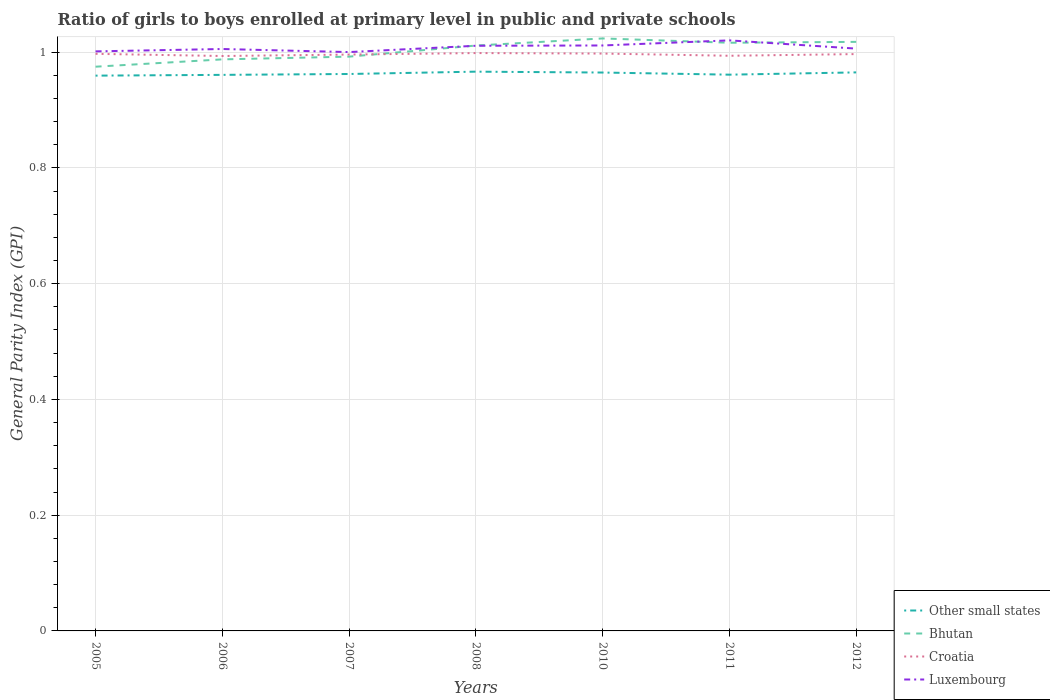How many different coloured lines are there?
Your response must be concise. 4. Is the number of lines equal to the number of legend labels?
Give a very brief answer. Yes. Across all years, what is the maximum general parity index in Croatia?
Keep it short and to the point. 0.99. In which year was the general parity index in Croatia maximum?
Your answer should be compact. 2006. What is the total general parity index in Other small states in the graph?
Ensure brevity in your answer.  -0. What is the difference between the highest and the second highest general parity index in Luxembourg?
Your answer should be compact. 0.02. Is the general parity index in Luxembourg strictly greater than the general parity index in Croatia over the years?
Give a very brief answer. No. How many years are there in the graph?
Your answer should be very brief. 7. Are the values on the major ticks of Y-axis written in scientific E-notation?
Offer a very short reply. No. Does the graph contain any zero values?
Give a very brief answer. No. Where does the legend appear in the graph?
Offer a terse response. Bottom right. How are the legend labels stacked?
Give a very brief answer. Vertical. What is the title of the graph?
Provide a short and direct response. Ratio of girls to boys enrolled at primary level in public and private schools. Does "Egypt, Arab Rep." appear as one of the legend labels in the graph?
Your answer should be very brief. No. What is the label or title of the X-axis?
Give a very brief answer. Years. What is the label or title of the Y-axis?
Ensure brevity in your answer.  General Parity Index (GPI). What is the General Parity Index (GPI) of Other small states in 2005?
Provide a succinct answer. 0.96. What is the General Parity Index (GPI) in Bhutan in 2005?
Your response must be concise. 0.97. What is the General Parity Index (GPI) of Croatia in 2005?
Keep it short and to the point. 1. What is the General Parity Index (GPI) in Luxembourg in 2005?
Your response must be concise. 1. What is the General Parity Index (GPI) in Other small states in 2006?
Your response must be concise. 0.96. What is the General Parity Index (GPI) in Bhutan in 2006?
Give a very brief answer. 0.99. What is the General Parity Index (GPI) in Croatia in 2006?
Make the answer very short. 0.99. What is the General Parity Index (GPI) in Luxembourg in 2006?
Your response must be concise. 1.01. What is the General Parity Index (GPI) in Other small states in 2007?
Provide a short and direct response. 0.96. What is the General Parity Index (GPI) in Bhutan in 2007?
Your answer should be very brief. 0.99. What is the General Parity Index (GPI) of Croatia in 2007?
Your response must be concise. 1. What is the General Parity Index (GPI) of Luxembourg in 2007?
Ensure brevity in your answer.  1. What is the General Parity Index (GPI) of Other small states in 2008?
Ensure brevity in your answer.  0.97. What is the General Parity Index (GPI) in Bhutan in 2008?
Keep it short and to the point. 1.01. What is the General Parity Index (GPI) of Croatia in 2008?
Offer a terse response. 1. What is the General Parity Index (GPI) in Luxembourg in 2008?
Provide a succinct answer. 1.01. What is the General Parity Index (GPI) in Other small states in 2010?
Offer a terse response. 0.96. What is the General Parity Index (GPI) in Bhutan in 2010?
Make the answer very short. 1.02. What is the General Parity Index (GPI) of Croatia in 2010?
Provide a succinct answer. 1. What is the General Parity Index (GPI) of Luxembourg in 2010?
Ensure brevity in your answer.  1.01. What is the General Parity Index (GPI) in Other small states in 2011?
Your answer should be compact. 0.96. What is the General Parity Index (GPI) of Bhutan in 2011?
Offer a very short reply. 1.02. What is the General Parity Index (GPI) in Croatia in 2011?
Make the answer very short. 0.99. What is the General Parity Index (GPI) of Luxembourg in 2011?
Your answer should be very brief. 1.02. What is the General Parity Index (GPI) in Other small states in 2012?
Offer a very short reply. 0.97. What is the General Parity Index (GPI) in Bhutan in 2012?
Keep it short and to the point. 1.02. What is the General Parity Index (GPI) of Croatia in 2012?
Make the answer very short. 1. What is the General Parity Index (GPI) of Luxembourg in 2012?
Offer a very short reply. 1.01. Across all years, what is the maximum General Parity Index (GPI) in Other small states?
Give a very brief answer. 0.97. Across all years, what is the maximum General Parity Index (GPI) in Bhutan?
Offer a terse response. 1.02. Across all years, what is the maximum General Parity Index (GPI) of Croatia?
Keep it short and to the point. 1. Across all years, what is the maximum General Parity Index (GPI) in Luxembourg?
Keep it short and to the point. 1.02. Across all years, what is the minimum General Parity Index (GPI) of Other small states?
Give a very brief answer. 0.96. Across all years, what is the minimum General Parity Index (GPI) of Bhutan?
Ensure brevity in your answer.  0.97. Across all years, what is the minimum General Parity Index (GPI) of Croatia?
Ensure brevity in your answer.  0.99. Across all years, what is the minimum General Parity Index (GPI) in Luxembourg?
Provide a succinct answer. 1. What is the total General Parity Index (GPI) of Other small states in the graph?
Your answer should be compact. 6.74. What is the total General Parity Index (GPI) in Bhutan in the graph?
Give a very brief answer. 7.02. What is the total General Parity Index (GPI) in Croatia in the graph?
Make the answer very short. 6.97. What is the total General Parity Index (GPI) of Luxembourg in the graph?
Offer a terse response. 7.06. What is the difference between the General Parity Index (GPI) in Other small states in 2005 and that in 2006?
Offer a terse response. -0. What is the difference between the General Parity Index (GPI) of Bhutan in 2005 and that in 2006?
Offer a very short reply. -0.01. What is the difference between the General Parity Index (GPI) of Croatia in 2005 and that in 2006?
Ensure brevity in your answer.  0. What is the difference between the General Parity Index (GPI) of Luxembourg in 2005 and that in 2006?
Keep it short and to the point. -0. What is the difference between the General Parity Index (GPI) in Other small states in 2005 and that in 2007?
Give a very brief answer. -0. What is the difference between the General Parity Index (GPI) in Bhutan in 2005 and that in 2007?
Offer a terse response. -0.02. What is the difference between the General Parity Index (GPI) in Croatia in 2005 and that in 2007?
Give a very brief answer. 0. What is the difference between the General Parity Index (GPI) of Luxembourg in 2005 and that in 2007?
Your answer should be very brief. 0. What is the difference between the General Parity Index (GPI) of Other small states in 2005 and that in 2008?
Your answer should be compact. -0.01. What is the difference between the General Parity Index (GPI) of Bhutan in 2005 and that in 2008?
Offer a very short reply. -0.04. What is the difference between the General Parity Index (GPI) of Croatia in 2005 and that in 2008?
Your answer should be compact. -0. What is the difference between the General Parity Index (GPI) in Luxembourg in 2005 and that in 2008?
Offer a very short reply. -0.01. What is the difference between the General Parity Index (GPI) in Other small states in 2005 and that in 2010?
Offer a terse response. -0.01. What is the difference between the General Parity Index (GPI) in Bhutan in 2005 and that in 2010?
Your response must be concise. -0.05. What is the difference between the General Parity Index (GPI) of Croatia in 2005 and that in 2010?
Provide a succinct answer. -0. What is the difference between the General Parity Index (GPI) of Luxembourg in 2005 and that in 2010?
Offer a terse response. -0.01. What is the difference between the General Parity Index (GPI) in Other small states in 2005 and that in 2011?
Offer a terse response. -0. What is the difference between the General Parity Index (GPI) of Bhutan in 2005 and that in 2011?
Keep it short and to the point. -0.04. What is the difference between the General Parity Index (GPI) of Croatia in 2005 and that in 2011?
Offer a terse response. 0. What is the difference between the General Parity Index (GPI) of Luxembourg in 2005 and that in 2011?
Your answer should be compact. -0.02. What is the difference between the General Parity Index (GPI) in Other small states in 2005 and that in 2012?
Make the answer very short. -0.01. What is the difference between the General Parity Index (GPI) in Bhutan in 2005 and that in 2012?
Your answer should be compact. -0.04. What is the difference between the General Parity Index (GPI) in Luxembourg in 2005 and that in 2012?
Give a very brief answer. -0. What is the difference between the General Parity Index (GPI) of Other small states in 2006 and that in 2007?
Make the answer very short. -0. What is the difference between the General Parity Index (GPI) in Bhutan in 2006 and that in 2007?
Your answer should be very brief. -0. What is the difference between the General Parity Index (GPI) in Croatia in 2006 and that in 2007?
Your response must be concise. -0. What is the difference between the General Parity Index (GPI) of Luxembourg in 2006 and that in 2007?
Make the answer very short. 0.01. What is the difference between the General Parity Index (GPI) in Other small states in 2006 and that in 2008?
Give a very brief answer. -0.01. What is the difference between the General Parity Index (GPI) of Bhutan in 2006 and that in 2008?
Keep it short and to the point. -0.02. What is the difference between the General Parity Index (GPI) of Croatia in 2006 and that in 2008?
Your answer should be compact. -0.01. What is the difference between the General Parity Index (GPI) in Luxembourg in 2006 and that in 2008?
Make the answer very short. -0.01. What is the difference between the General Parity Index (GPI) of Other small states in 2006 and that in 2010?
Your response must be concise. -0. What is the difference between the General Parity Index (GPI) of Bhutan in 2006 and that in 2010?
Provide a short and direct response. -0.04. What is the difference between the General Parity Index (GPI) in Croatia in 2006 and that in 2010?
Make the answer very short. -0. What is the difference between the General Parity Index (GPI) in Luxembourg in 2006 and that in 2010?
Give a very brief answer. -0.01. What is the difference between the General Parity Index (GPI) of Other small states in 2006 and that in 2011?
Give a very brief answer. -0. What is the difference between the General Parity Index (GPI) in Bhutan in 2006 and that in 2011?
Give a very brief answer. -0.03. What is the difference between the General Parity Index (GPI) in Croatia in 2006 and that in 2011?
Provide a succinct answer. -0. What is the difference between the General Parity Index (GPI) in Luxembourg in 2006 and that in 2011?
Keep it short and to the point. -0.01. What is the difference between the General Parity Index (GPI) of Other small states in 2006 and that in 2012?
Provide a short and direct response. -0. What is the difference between the General Parity Index (GPI) of Bhutan in 2006 and that in 2012?
Make the answer very short. -0.03. What is the difference between the General Parity Index (GPI) in Croatia in 2006 and that in 2012?
Offer a very short reply. -0. What is the difference between the General Parity Index (GPI) in Luxembourg in 2006 and that in 2012?
Provide a succinct answer. -0. What is the difference between the General Parity Index (GPI) in Other small states in 2007 and that in 2008?
Keep it short and to the point. -0. What is the difference between the General Parity Index (GPI) in Bhutan in 2007 and that in 2008?
Your answer should be very brief. -0.02. What is the difference between the General Parity Index (GPI) of Croatia in 2007 and that in 2008?
Ensure brevity in your answer.  -0. What is the difference between the General Parity Index (GPI) in Luxembourg in 2007 and that in 2008?
Offer a terse response. -0.01. What is the difference between the General Parity Index (GPI) in Other small states in 2007 and that in 2010?
Your response must be concise. -0. What is the difference between the General Parity Index (GPI) of Bhutan in 2007 and that in 2010?
Ensure brevity in your answer.  -0.03. What is the difference between the General Parity Index (GPI) of Croatia in 2007 and that in 2010?
Ensure brevity in your answer.  -0. What is the difference between the General Parity Index (GPI) in Luxembourg in 2007 and that in 2010?
Your answer should be very brief. -0.01. What is the difference between the General Parity Index (GPI) in Other small states in 2007 and that in 2011?
Offer a very short reply. 0. What is the difference between the General Parity Index (GPI) of Bhutan in 2007 and that in 2011?
Make the answer very short. -0.02. What is the difference between the General Parity Index (GPI) in Croatia in 2007 and that in 2011?
Offer a very short reply. 0. What is the difference between the General Parity Index (GPI) of Luxembourg in 2007 and that in 2011?
Your answer should be compact. -0.02. What is the difference between the General Parity Index (GPI) of Other small states in 2007 and that in 2012?
Provide a short and direct response. -0. What is the difference between the General Parity Index (GPI) in Bhutan in 2007 and that in 2012?
Your response must be concise. -0.03. What is the difference between the General Parity Index (GPI) in Croatia in 2007 and that in 2012?
Your response must be concise. -0. What is the difference between the General Parity Index (GPI) in Luxembourg in 2007 and that in 2012?
Ensure brevity in your answer.  -0.01. What is the difference between the General Parity Index (GPI) in Other small states in 2008 and that in 2010?
Offer a very short reply. 0. What is the difference between the General Parity Index (GPI) in Bhutan in 2008 and that in 2010?
Provide a succinct answer. -0.01. What is the difference between the General Parity Index (GPI) of Croatia in 2008 and that in 2010?
Provide a succinct answer. 0. What is the difference between the General Parity Index (GPI) of Luxembourg in 2008 and that in 2010?
Ensure brevity in your answer.  -0. What is the difference between the General Parity Index (GPI) in Other small states in 2008 and that in 2011?
Offer a terse response. 0.01. What is the difference between the General Parity Index (GPI) of Bhutan in 2008 and that in 2011?
Your answer should be compact. -0. What is the difference between the General Parity Index (GPI) in Croatia in 2008 and that in 2011?
Provide a short and direct response. 0. What is the difference between the General Parity Index (GPI) of Luxembourg in 2008 and that in 2011?
Make the answer very short. -0.01. What is the difference between the General Parity Index (GPI) of Other small states in 2008 and that in 2012?
Ensure brevity in your answer.  0. What is the difference between the General Parity Index (GPI) of Bhutan in 2008 and that in 2012?
Your response must be concise. -0.01. What is the difference between the General Parity Index (GPI) in Croatia in 2008 and that in 2012?
Keep it short and to the point. 0. What is the difference between the General Parity Index (GPI) of Luxembourg in 2008 and that in 2012?
Give a very brief answer. 0. What is the difference between the General Parity Index (GPI) of Other small states in 2010 and that in 2011?
Give a very brief answer. 0. What is the difference between the General Parity Index (GPI) of Bhutan in 2010 and that in 2011?
Make the answer very short. 0.01. What is the difference between the General Parity Index (GPI) in Croatia in 2010 and that in 2011?
Make the answer very short. 0. What is the difference between the General Parity Index (GPI) of Luxembourg in 2010 and that in 2011?
Keep it short and to the point. -0.01. What is the difference between the General Parity Index (GPI) in Other small states in 2010 and that in 2012?
Give a very brief answer. -0. What is the difference between the General Parity Index (GPI) in Bhutan in 2010 and that in 2012?
Ensure brevity in your answer.  0.01. What is the difference between the General Parity Index (GPI) in Croatia in 2010 and that in 2012?
Give a very brief answer. 0. What is the difference between the General Parity Index (GPI) in Luxembourg in 2010 and that in 2012?
Offer a very short reply. 0.01. What is the difference between the General Parity Index (GPI) of Other small states in 2011 and that in 2012?
Offer a very short reply. -0. What is the difference between the General Parity Index (GPI) in Bhutan in 2011 and that in 2012?
Provide a succinct answer. -0. What is the difference between the General Parity Index (GPI) in Croatia in 2011 and that in 2012?
Your response must be concise. -0. What is the difference between the General Parity Index (GPI) of Luxembourg in 2011 and that in 2012?
Give a very brief answer. 0.01. What is the difference between the General Parity Index (GPI) of Other small states in 2005 and the General Parity Index (GPI) of Bhutan in 2006?
Offer a terse response. -0.03. What is the difference between the General Parity Index (GPI) in Other small states in 2005 and the General Parity Index (GPI) in Croatia in 2006?
Give a very brief answer. -0.03. What is the difference between the General Parity Index (GPI) in Other small states in 2005 and the General Parity Index (GPI) in Luxembourg in 2006?
Make the answer very short. -0.05. What is the difference between the General Parity Index (GPI) of Bhutan in 2005 and the General Parity Index (GPI) of Croatia in 2006?
Offer a terse response. -0.02. What is the difference between the General Parity Index (GPI) in Bhutan in 2005 and the General Parity Index (GPI) in Luxembourg in 2006?
Offer a very short reply. -0.03. What is the difference between the General Parity Index (GPI) in Croatia in 2005 and the General Parity Index (GPI) in Luxembourg in 2006?
Offer a terse response. -0.01. What is the difference between the General Parity Index (GPI) of Other small states in 2005 and the General Parity Index (GPI) of Bhutan in 2007?
Provide a succinct answer. -0.03. What is the difference between the General Parity Index (GPI) in Other small states in 2005 and the General Parity Index (GPI) in Croatia in 2007?
Give a very brief answer. -0.04. What is the difference between the General Parity Index (GPI) of Other small states in 2005 and the General Parity Index (GPI) of Luxembourg in 2007?
Your answer should be very brief. -0.04. What is the difference between the General Parity Index (GPI) of Bhutan in 2005 and the General Parity Index (GPI) of Croatia in 2007?
Your answer should be very brief. -0.02. What is the difference between the General Parity Index (GPI) in Bhutan in 2005 and the General Parity Index (GPI) in Luxembourg in 2007?
Make the answer very short. -0.03. What is the difference between the General Parity Index (GPI) in Croatia in 2005 and the General Parity Index (GPI) in Luxembourg in 2007?
Offer a terse response. -0. What is the difference between the General Parity Index (GPI) of Other small states in 2005 and the General Parity Index (GPI) of Bhutan in 2008?
Offer a terse response. -0.05. What is the difference between the General Parity Index (GPI) in Other small states in 2005 and the General Parity Index (GPI) in Croatia in 2008?
Your answer should be compact. -0.04. What is the difference between the General Parity Index (GPI) in Other small states in 2005 and the General Parity Index (GPI) in Luxembourg in 2008?
Your answer should be compact. -0.05. What is the difference between the General Parity Index (GPI) in Bhutan in 2005 and the General Parity Index (GPI) in Croatia in 2008?
Your answer should be very brief. -0.02. What is the difference between the General Parity Index (GPI) in Bhutan in 2005 and the General Parity Index (GPI) in Luxembourg in 2008?
Your answer should be very brief. -0.04. What is the difference between the General Parity Index (GPI) in Croatia in 2005 and the General Parity Index (GPI) in Luxembourg in 2008?
Offer a very short reply. -0.01. What is the difference between the General Parity Index (GPI) in Other small states in 2005 and the General Parity Index (GPI) in Bhutan in 2010?
Keep it short and to the point. -0.06. What is the difference between the General Parity Index (GPI) of Other small states in 2005 and the General Parity Index (GPI) of Croatia in 2010?
Your response must be concise. -0.04. What is the difference between the General Parity Index (GPI) in Other small states in 2005 and the General Parity Index (GPI) in Luxembourg in 2010?
Your answer should be very brief. -0.05. What is the difference between the General Parity Index (GPI) of Bhutan in 2005 and the General Parity Index (GPI) of Croatia in 2010?
Offer a terse response. -0.02. What is the difference between the General Parity Index (GPI) of Bhutan in 2005 and the General Parity Index (GPI) of Luxembourg in 2010?
Provide a short and direct response. -0.04. What is the difference between the General Parity Index (GPI) of Croatia in 2005 and the General Parity Index (GPI) of Luxembourg in 2010?
Your answer should be compact. -0.01. What is the difference between the General Parity Index (GPI) of Other small states in 2005 and the General Parity Index (GPI) of Bhutan in 2011?
Your answer should be compact. -0.06. What is the difference between the General Parity Index (GPI) of Other small states in 2005 and the General Parity Index (GPI) of Croatia in 2011?
Provide a short and direct response. -0.03. What is the difference between the General Parity Index (GPI) of Other small states in 2005 and the General Parity Index (GPI) of Luxembourg in 2011?
Your response must be concise. -0.06. What is the difference between the General Parity Index (GPI) in Bhutan in 2005 and the General Parity Index (GPI) in Croatia in 2011?
Provide a short and direct response. -0.02. What is the difference between the General Parity Index (GPI) of Bhutan in 2005 and the General Parity Index (GPI) of Luxembourg in 2011?
Give a very brief answer. -0.05. What is the difference between the General Parity Index (GPI) in Croatia in 2005 and the General Parity Index (GPI) in Luxembourg in 2011?
Ensure brevity in your answer.  -0.02. What is the difference between the General Parity Index (GPI) of Other small states in 2005 and the General Parity Index (GPI) of Bhutan in 2012?
Keep it short and to the point. -0.06. What is the difference between the General Parity Index (GPI) in Other small states in 2005 and the General Parity Index (GPI) in Croatia in 2012?
Offer a very short reply. -0.04. What is the difference between the General Parity Index (GPI) of Other small states in 2005 and the General Parity Index (GPI) of Luxembourg in 2012?
Provide a succinct answer. -0.05. What is the difference between the General Parity Index (GPI) of Bhutan in 2005 and the General Parity Index (GPI) of Croatia in 2012?
Your answer should be compact. -0.02. What is the difference between the General Parity Index (GPI) in Bhutan in 2005 and the General Parity Index (GPI) in Luxembourg in 2012?
Provide a succinct answer. -0.03. What is the difference between the General Parity Index (GPI) of Croatia in 2005 and the General Parity Index (GPI) of Luxembourg in 2012?
Your answer should be very brief. -0.01. What is the difference between the General Parity Index (GPI) of Other small states in 2006 and the General Parity Index (GPI) of Bhutan in 2007?
Ensure brevity in your answer.  -0.03. What is the difference between the General Parity Index (GPI) of Other small states in 2006 and the General Parity Index (GPI) of Croatia in 2007?
Provide a succinct answer. -0.04. What is the difference between the General Parity Index (GPI) in Other small states in 2006 and the General Parity Index (GPI) in Luxembourg in 2007?
Provide a succinct answer. -0.04. What is the difference between the General Parity Index (GPI) of Bhutan in 2006 and the General Parity Index (GPI) of Croatia in 2007?
Offer a terse response. -0.01. What is the difference between the General Parity Index (GPI) of Bhutan in 2006 and the General Parity Index (GPI) of Luxembourg in 2007?
Your response must be concise. -0.01. What is the difference between the General Parity Index (GPI) of Croatia in 2006 and the General Parity Index (GPI) of Luxembourg in 2007?
Offer a terse response. -0.01. What is the difference between the General Parity Index (GPI) of Other small states in 2006 and the General Parity Index (GPI) of Bhutan in 2008?
Your answer should be very brief. -0.05. What is the difference between the General Parity Index (GPI) of Other small states in 2006 and the General Parity Index (GPI) of Croatia in 2008?
Your answer should be very brief. -0.04. What is the difference between the General Parity Index (GPI) of Other small states in 2006 and the General Parity Index (GPI) of Luxembourg in 2008?
Your answer should be very brief. -0.05. What is the difference between the General Parity Index (GPI) in Bhutan in 2006 and the General Parity Index (GPI) in Croatia in 2008?
Your answer should be very brief. -0.01. What is the difference between the General Parity Index (GPI) of Bhutan in 2006 and the General Parity Index (GPI) of Luxembourg in 2008?
Provide a short and direct response. -0.02. What is the difference between the General Parity Index (GPI) of Croatia in 2006 and the General Parity Index (GPI) of Luxembourg in 2008?
Offer a very short reply. -0.02. What is the difference between the General Parity Index (GPI) of Other small states in 2006 and the General Parity Index (GPI) of Bhutan in 2010?
Provide a succinct answer. -0.06. What is the difference between the General Parity Index (GPI) of Other small states in 2006 and the General Parity Index (GPI) of Croatia in 2010?
Offer a terse response. -0.04. What is the difference between the General Parity Index (GPI) in Other small states in 2006 and the General Parity Index (GPI) in Luxembourg in 2010?
Provide a succinct answer. -0.05. What is the difference between the General Parity Index (GPI) in Bhutan in 2006 and the General Parity Index (GPI) in Croatia in 2010?
Your answer should be very brief. -0.01. What is the difference between the General Parity Index (GPI) in Bhutan in 2006 and the General Parity Index (GPI) in Luxembourg in 2010?
Make the answer very short. -0.02. What is the difference between the General Parity Index (GPI) of Croatia in 2006 and the General Parity Index (GPI) of Luxembourg in 2010?
Your answer should be very brief. -0.02. What is the difference between the General Parity Index (GPI) of Other small states in 2006 and the General Parity Index (GPI) of Bhutan in 2011?
Provide a succinct answer. -0.06. What is the difference between the General Parity Index (GPI) in Other small states in 2006 and the General Parity Index (GPI) in Croatia in 2011?
Ensure brevity in your answer.  -0.03. What is the difference between the General Parity Index (GPI) in Other small states in 2006 and the General Parity Index (GPI) in Luxembourg in 2011?
Offer a very short reply. -0.06. What is the difference between the General Parity Index (GPI) of Bhutan in 2006 and the General Parity Index (GPI) of Croatia in 2011?
Offer a very short reply. -0.01. What is the difference between the General Parity Index (GPI) of Bhutan in 2006 and the General Parity Index (GPI) of Luxembourg in 2011?
Provide a succinct answer. -0.03. What is the difference between the General Parity Index (GPI) in Croatia in 2006 and the General Parity Index (GPI) in Luxembourg in 2011?
Provide a succinct answer. -0.03. What is the difference between the General Parity Index (GPI) in Other small states in 2006 and the General Parity Index (GPI) in Bhutan in 2012?
Your answer should be very brief. -0.06. What is the difference between the General Parity Index (GPI) of Other small states in 2006 and the General Parity Index (GPI) of Croatia in 2012?
Offer a very short reply. -0.04. What is the difference between the General Parity Index (GPI) in Other small states in 2006 and the General Parity Index (GPI) in Luxembourg in 2012?
Offer a terse response. -0.05. What is the difference between the General Parity Index (GPI) of Bhutan in 2006 and the General Parity Index (GPI) of Croatia in 2012?
Provide a succinct answer. -0.01. What is the difference between the General Parity Index (GPI) of Bhutan in 2006 and the General Parity Index (GPI) of Luxembourg in 2012?
Make the answer very short. -0.02. What is the difference between the General Parity Index (GPI) of Croatia in 2006 and the General Parity Index (GPI) of Luxembourg in 2012?
Your response must be concise. -0.01. What is the difference between the General Parity Index (GPI) of Other small states in 2007 and the General Parity Index (GPI) of Bhutan in 2008?
Keep it short and to the point. -0.05. What is the difference between the General Parity Index (GPI) in Other small states in 2007 and the General Parity Index (GPI) in Croatia in 2008?
Offer a very short reply. -0.04. What is the difference between the General Parity Index (GPI) of Other small states in 2007 and the General Parity Index (GPI) of Luxembourg in 2008?
Ensure brevity in your answer.  -0.05. What is the difference between the General Parity Index (GPI) of Bhutan in 2007 and the General Parity Index (GPI) of Croatia in 2008?
Your answer should be compact. -0.01. What is the difference between the General Parity Index (GPI) in Bhutan in 2007 and the General Parity Index (GPI) in Luxembourg in 2008?
Provide a succinct answer. -0.02. What is the difference between the General Parity Index (GPI) of Croatia in 2007 and the General Parity Index (GPI) of Luxembourg in 2008?
Your answer should be compact. -0.02. What is the difference between the General Parity Index (GPI) of Other small states in 2007 and the General Parity Index (GPI) of Bhutan in 2010?
Make the answer very short. -0.06. What is the difference between the General Parity Index (GPI) of Other small states in 2007 and the General Parity Index (GPI) of Croatia in 2010?
Your response must be concise. -0.04. What is the difference between the General Parity Index (GPI) in Other small states in 2007 and the General Parity Index (GPI) in Luxembourg in 2010?
Ensure brevity in your answer.  -0.05. What is the difference between the General Parity Index (GPI) in Bhutan in 2007 and the General Parity Index (GPI) in Croatia in 2010?
Your response must be concise. -0.01. What is the difference between the General Parity Index (GPI) in Bhutan in 2007 and the General Parity Index (GPI) in Luxembourg in 2010?
Provide a succinct answer. -0.02. What is the difference between the General Parity Index (GPI) of Croatia in 2007 and the General Parity Index (GPI) of Luxembourg in 2010?
Make the answer very short. -0.02. What is the difference between the General Parity Index (GPI) in Other small states in 2007 and the General Parity Index (GPI) in Bhutan in 2011?
Ensure brevity in your answer.  -0.05. What is the difference between the General Parity Index (GPI) of Other small states in 2007 and the General Parity Index (GPI) of Croatia in 2011?
Keep it short and to the point. -0.03. What is the difference between the General Parity Index (GPI) of Other small states in 2007 and the General Parity Index (GPI) of Luxembourg in 2011?
Provide a short and direct response. -0.06. What is the difference between the General Parity Index (GPI) in Bhutan in 2007 and the General Parity Index (GPI) in Croatia in 2011?
Your response must be concise. -0. What is the difference between the General Parity Index (GPI) in Bhutan in 2007 and the General Parity Index (GPI) in Luxembourg in 2011?
Your answer should be compact. -0.03. What is the difference between the General Parity Index (GPI) in Croatia in 2007 and the General Parity Index (GPI) in Luxembourg in 2011?
Give a very brief answer. -0.02. What is the difference between the General Parity Index (GPI) of Other small states in 2007 and the General Parity Index (GPI) of Bhutan in 2012?
Ensure brevity in your answer.  -0.06. What is the difference between the General Parity Index (GPI) in Other small states in 2007 and the General Parity Index (GPI) in Croatia in 2012?
Offer a terse response. -0.03. What is the difference between the General Parity Index (GPI) of Other small states in 2007 and the General Parity Index (GPI) of Luxembourg in 2012?
Give a very brief answer. -0.04. What is the difference between the General Parity Index (GPI) of Bhutan in 2007 and the General Parity Index (GPI) of Croatia in 2012?
Offer a terse response. -0. What is the difference between the General Parity Index (GPI) in Bhutan in 2007 and the General Parity Index (GPI) in Luxembourg in 2012?
Provide a short and direct response. -0.01. What is the difference between the General Parity Index (GPI) of Croatia in 2007 and the General Parity Index (GPI) of Luxembourg in 2012?
Offer a very short reply. -0.01. What is the difference between the General Parity Index (GPI) in Other small states in 2008 and the General Parity Index (GPI) in Bhutan in 2010?
Provide a short and direct response. -0.06. What is the difference between the General Parity Index (GPI) of Other small states in 2008 and the General Parity Index (GPI) of Croatia in 2010?
Provide a short and direct response. -0.03. What is the difference between the General Parity Index (GPI) of Other small states in 2008 and the General Parity Index (GPI) of Luxembourg in 2010?
Give a very brief answer. -0.05. What is the difference between the General Parity Index (GPI) of Bhutan in 2008 and the General Parity Index (GPI) of Croatia in 2010?
Keep it short and to the point. 0.01. What is the difference between the General Parity Index (GPI) of Bhutan in 2008 and the General Parity Index (GPI) of Luxembourg in 2010?
Offer a very short reply. -0. What is the difference between the General Parity Index (GPI) in Croatia in 2008 and the General Parity Index (GPI) in Luxembourg in 2010?
Provide a short and direct response. -0.01. What is the difference between the General Parity Index (GPI) in Other small states in 2008 and the General Parity Index (GPI) in Croatia in 2011?
Keep it short and to the point. -0.03. What is the difference between the General Parity Index (GPI) of Other small states in 2008 and the General Parity Index (GPI) of Luxembourg in 2011?
Provide a short and direct response. -0.05. What is the difference between the General Parity Index (GPI) of Bhutan in 2008 and the General Parity Index (GPI) of Croatia in 2011?
Your response must be concise. 0.02. What is the difference between the General Parity Index (GPI) of Bhutan in 2008 and the General Parity Index (GPI) of Luxembourg in 2011?
Your answer should be very brief. -0.01. What is the difference between the General Parity Index (GPI) in Croatia in 2008 and the General Parity Index (GPI) in Luxembourg in 2011?
Ensure brevity in your answer.  -0.02. What is the difference between the General Parity Index (GPI) in Other small states in 2008 and the General Parity Index (GPI) in Bhutan in 2012?
Provide a short and direct response. -0.05. What is the difference between the General Parity Index (GPI) in Other small states in 2008 and the General Parity Index (GPI) in Croatia in 2012?
Make the answer very short. -0.03. What is the difference between the General Parity Index (GPI) of Other small states in 2008 and the General Parity Index (GPI) of Luxembourg in 2012?
Offer a terse response. -0.04. What is the difference between the General Parity Index (GPI) of Bhutan in 2008 and the General Parity Index (GPI) of Croatia in 2012?
Offer a terse response. 0.01. What is the difference between the General Parity Index (GPI) in Bhutan in 2008 and the General Parity Index (GPI) in Luxembourg in 2012?
Make the answer very short. 0.01. What is the difference between the General Parity Index (GPI) in Croatia in 2008 and the General Parity Index (GPI) in Luxembourg in 2012?
Offer a terse response. -0.01. What is the difference between the General Parity Index (GPI) of Other small states in 2010 and the General Parity Index (GPI) of Bhutan in 2011?
Keep it short and to the point. -0.05. What is the difference between the General Parity Index (GPI) of Other small states in 2010 and the General Parity Index (GPI) of Croatia in 2011?
Your answer should be compact. -0.03. What is the difference between the General Parity Index (GPI) of Other small states in 2010 and the General Parity Index (GPI) of Luxembourg in 2011?
Provide a succinct answer. -0.06. What is the difference between the General Parity Index (GPI) in Bhutan in 2010 and the General Parity Index (GPI) in Croatia in 2011?
Provide a short and direct response. 0.03. What is the difference between the General Parity Index (GPI) in Bhutan in 2010 and the General Parity Index (GPI) in Luxembourg in 2011?
Make the answer very short. 0. What is the difference between the General Parity Index (GPI) of Croatia in 2010 and the General Parity Index (GPI) of Luxembourg in 2011?
Ensure brevity in your answer.  -0.02. What is the difference between the General Parity Index (GPI) in Other small states in 2010 and the General Parity Index (GPI) in Bhutan in 2012?
Ensure brevity in your answer.  -0.05. What is the difference between the General Parity Index (GPI) in Other small states in 2010 and the General Parity Index (GPI) in Croatia in 2012?
Offer a terse response. -0.03. What is the difference between the General Parity Index (GPI) of Other small states in 2010 and the General Parity Index (GPI) of Luxembourg in 2012?
Your answer should be very brief. -0.04. What is the difference between the General Parity Index (GPI) in Bhutan in 2010 and the General Parity Index (GPI) in Croatia in 2012?
Provide a short and direct response. 0.03. What is the difference between the General Parity Index (GPI) of Bhutan in 2010 and the General Parity Index (GPI) of Luxembourg in 2012?
Your answer should be compact. 0.02. What is the difference between the General Parity Index (GPI) of Croatia in 2010 and the General Parity Index (GPI) of Luxembourg in 2012?
Keep it short and to the point. -0.01. What is the difference between the General Parity Index (GPI) in Other small states in 2011 and the General Parity Index (GPI) in Bhutan in 2012?
Offer a very short reply. -0.06. What is the difference between the General Parity Index (GPI) in Other small states in 2011 and the General Parity Index (GPI) in Croatia in 2012?
Your answer should be very brief. -0.04. What is the difference between the General Parity Index (GPI) in Other small states in 2011 and the General Parity Index (GPI) in Luxembourg in 2012?
Offer a terse response. -0.04. What is the difference between the General Parity Index (GPI) in Bhutan in 2011 and the General Parity Index (GPI) in Croatia in 2012?
Provide a short and direct response. 0.02. What is the difference between the General Parity Index (GPI) of Bhutan in 2011 and the General Parity Index (GPI) of Luxembourg in 2012?
Provide a short and direct response. 0.01. What is the difference between the General Parity Index (GPI) in Croatia in 2011 and the General Parity Index (GPI) in Luxembourg in 2012?
Provide a short and direct response. -0.01. What is the average General Parity Index (GPI) of Other small states per year?
Your answer should be very brief. 0.96. In the year 2005, what is the difference between the General Parity Index (GPI) of Other small states and General Parity Index (GPI) of Bhutan?
Offer a very short reply. -0.02. In the year 2005, what is the difference between the General Parity Index (GPI) in Other small states and General Parity Index (GPI) in Croatia?
Provide a short and direct response. -0.04. In the year 2005, what is the difference between the General Parity Index (GPI) in Other small states and General Parity Index (GPI) in Luxembourg?
Ensure brevity in your answer.  -0.04. In the year 2005, what is the difference between the General Parity Index (GPI) of Bhutan and General Parity Index (GPI) of Croatia?
Provide a short and direct response. -0.02. In the year 2005, what is the difference between the General Parity Index (GPI) of Bhutan and General Parity Index (GPI) of Luxembourg?
Your response must be concise. -0.03. In the year 2005, what is the difference between the General Parity Index (GPI) in Croatia and General Parity Index (GPI) in Luxembourg?
Provide a short and direct response. -0. In the year 2006, what is the difference between the General Parity Index (GPI) in Other small states and General Parity Index (GPI) in Bhutan?
Ensure brevity in your answer.  -0.03. In the year 2006, what is the difference between the General Parity Index (GPI) in Other small states and General Parity Index (GPI) in Croatia?
Provide a succinct answer. -0.03. In the year 2006, what is the difference between the General Parity Index (GPI) in Other small states and General Parity Index (GPI) in Luxembourg?
Your response must be concise. -0.04. In the year 2006, what is the difference between the General Parity Index (GPI) of Bhutan and General Parity Index (GPI) of Croatia?
Keep it short and to the point. -0.01. In the year 2006, what is the difference between the General Parity Index (GPI) of Bhutan and General Parity Index (GPI) of Luxembourg?
Give a very brief answer. -0.02. In the year 2006, what is the difference between the General Parity Index (GPI) in Croatia and General Parity Index (GPI) in Luxembourg?
Your answer should be compact. -0.01. In the year 2007, what is the difference between the General Parity Index (GPI) of Other small states and General Parity Index (GPI) of Bhutan?
Offer a very short reply. -0.03. In the year 2007, what is the difference between the General Parity Index (GPI) in Other small states and General Parity Index (GPI) in Croatia?
Your answer should be very brief. -0.03. In the year 2007, what is the difference between the General Parity Index (GPI) of Other small states and General Parity Index (GPI) of Luxembourg?
Your answer should be compact. -0.04. In the year 2007, what is the difference between the General Parity Index (GPI) in Bhutan and General Parity Index (GPI) in Croatia?
Offer a very short reply. -0. In the year 2007, what is the difference between the General Parity Index (GPI) of Bhutan and General Parity Index (GPI) of Luxembourg?
Ensure brevity in your answer.  -0.01. In the year 2007, what is the difference between the General Parity Index (GPI) of Croatia and General Parity Index (GPI) of Luxembourg?
Your answer should be compact. -0. In the year 2008, what is the difference between the General Parity Index (GPI) in Other small states and General Parity Index (GPI) in Bhutan?
Offer a very short reply. -0.05. In the year 2008, what is the difference between the General Parity Index (GPI) of Other small states and General Parity Index (GPI) of Croatia?
Make the answer very short. -0.03. In the year 2008, what is the difference between the General Parity Index (GPI) of Other small states and General Parity Index (GPI) of Luxembourg?
Your answer should be very brief. -0.04. In the year 2008, what is the difference between the General Parity Index (GPI) in Bhutan and General Parity Index (GPI) in Croatia?
Keep it short and to the point. 0.01. In the year 2008, what is the difference between the General Parity Index (GPI) in Bhutan and General Parity Index (GPI) in Luxembourg?
Your answer should be very brief. 0. In the year 2008, what is the difference between the General Parity Index (GPI) of Croatia and General Parity Index (GPI) of Luxembourg?
Give a very brief answer. -0.01. In the year 2010, what is the difference between the General Parity Index (GPI) in Other small states and General Parity Index (GPI) in Bhutan?
Provide a short and direct response. -0.06. In the year 2010, what is the difference between the General Parity Index (GPI) in Other small states and General Parity Index (GPI) in Croatia?
Offer a very short reply. -0.03. In the year 2010, what is the difference between the General Parity Index (GPI) in Other small states and General Parity Index (GPI) in Luxembourg?
Offer a very short reply. -0.05. In the year 2010, what is the difference between the General Parity Index (GPI) of Bhutan and General Parity Index (GPI) of Croatia?
Provide a succinct answer. 0.03. In the year 2010, what is the difference between the General Parity Index (GPI) of Bhutan and General Parity Index (GPI) of Luxembourg?
Provide a succinct answer. 0.01. In the year 2010, what is the difference between the General Parity Index (GPI) in Croatia and General Parity Index (GPI) in Luxembourg?
Offer a very short reply. -0.01. In the year 2011, what is the difference between the General Parity Index (GPI) in Other small states and General Parity Index (GPI) in Bhutan?
Provide a short and direct response. -0.06. In the year 2011, what is the difference between the General Parity Index (GPI) of Other small states and General Parity Index (GPI) of Croatia?
Provide a succinct answer. -0.03. In the year 2011, what is the difference between the General Parity Index (GPI) in Other small states and General Parity Index (GPI) in Luxembourg?
Provide a short and direct response. -0.06. In the year 2011, what is the difference between the General Parity Index (GPI) in Bhutan and General Parity Index (GPI) in Croatia?
Offer a terse response. 0.02. In the year 2011, what is the difference between the General Parity Index (GPI) in Bhutan and General Parity Index (GPI) in Luxembourg?
Your answer should be compact. -0. In the year 2011, what is the difference between the General Parity Index (GPI) of Croatia and General Parity Index (GPI) of Luxembourg?
Your response must be concise. -0.03. In the year 2012, what is the difference between the General Parity Index (GPI) of Other small states and General Parity Index (GPI) of Bhutan?
Make the answer very short. -0.05. In the year 2012, what is the difference between the General Parity Index (GPI) in Other small states and General Parity Index (GPI) in Croatia?
Provide a short and direct response. -0.03. In the year 2012, what is the difference between the General Parity Index (GPI) of Other small states and General Parity Index (GPI) of Luxembourg?
Provide a short and direct response. -0.04. In the year 2012, what is the difference between the General Parity Index (GPI) in Bhutan and General Parity Index (GPI) in Croatia?
Ensure brevity in your answer.  0.02. In the year 2012, what is the difference between the General Parity Index (GPI) of Bhutan and General Parity Index (GPI) of Luxembourg?
Make the answer very short. 0.01. In the year 2012, what is the difference between the General Parity Index (GPI) in Croatia and General Parity Index (GPI) in Luxembourg?
Give a very brief answer. -0.01. What is the ratio of the General Parity Index (GPI) in Other small states in 2005 to that in 2006?
Offer a very short reply. 1. What is the ratio of the General Parity Index (GPI) in Bhutan in 2005 to that in 2006?
Your response must be concise. 0.99. What is the ratio of the General Parity Index (GPI) of Croatia in 2005 to that in 2006?
Your response must be concise. 1. What is the ratio of the General Parity Index (GPI) of Luxembourg in 2005 to that in 2006?
Make the answer very short. 1. What is the ratio of the General Parity Index (GPI) of Bhutan in 2005 to that in 2007?
Your answer should be compact. 0.98. What is the ratio of the General Parity Index (GPI) of Croatia in 2005 to that in 2007?
Provide a succinct answer. 1. What is the ratio of the General Parity Index (GPI) in Other small states in 2005 to that in 2008?
Offer a very short reply. 0.99. What is the ratio of the General Parity Index (GPI) in Bhutan in 2005 to that in 2008?
Provide a succinct answer. 0.96. What is the ratio of the General Parity Index (GPI) in Croatia in 2005 to that in 2008?
Offer a very short reply. 1. What is the ratio of the General Parity Index (GPI) of Other small states in 2005 to that in 2010?
Offer a terse response. 0.99. What is the ratio of the General Parity Index (GPI) in Bhutan in 2005 to that in 2010?
Your answer should be compact. 0.95. What is the ratio of the General Parity Index (GPI) in Bhutan in 2005 to that in 2011?
Give a very brief answer. 0.96. What is the ratio of the General Parity Index (GPI) of Croatia in 2005 to that in 2011?
Provide a succinct answer. 1. What is the ratio of the General Parity Index (GPI) of Luxembourg in 2005 to that in 2011?
Your answer should be compact. 0.98. What is the ratio of the General Parity Index (GPI) of Bhutan in 2005 to that in 2012?
Make the answer very short. 0.96. What is the ratio of the General Parity Index (GPI) in Luxembourg in 2005 to that in 2012?
Offer a terse response. 1. What is the ratio of the General Parity Index (GPI) in Other small states in 2006 to that in 2008?
Give a very brief answer. 0.99. What is the ratio of the General Parity Index (GPI) in Bhutan in 2006 to that in 2008?
Your answer should be compact. 0.98. What is the ratio of the General Parity Index (GPI) in Bhutan in 2006 to that in 2010?
Provide a short and direct response. 0.96. What is the ratio of the General Parity Index (GPI) in Croatia in 2006 to that in 2010?
Keep it short and to the point. 1. What is the ratio of the General Parity Index (GPI) of Luxembourg in 2006 to that in 2010?
Your answer should be very brief. 0.99. What is the ratio of the General Parity Index (GPI) in Bhutan in 2006 to that in 2011?
Provide a succinct answer. 0.97. What is the ratio of the General Parity Index (GPI) of Luxembourg in 2006 to that in 2011?
Give a very brief answer. 0.99. What is the ratio of the General Parity Index (GPI) of Other small states in 2006 to that in 2012?
Give a very brief answer. 1. What is the ratio of the General Parity Index (GPI) of Bhutan in 2006 to that in 2012?
Make the answer very short. 0.97. What is the ratio of the General Parity Index (GPI) in Croatia in 2006 to that in 2012?
Provide a short and direct response. 1. What is the ratio of the General Parity Index (GPI) in Luxembourg in 2006 to that in 2012?
Provide a succinct answer. 1. What is the ratio of the General Parity Index (GPI) of Bhutan in 2007 to that in 2008?
Your answer should be very brief. 0.98. What is the ratio of the General Parity Index (GPI) in Croatia in 2007 to that in 2008?
Offer a terse response. 1. What is the ratio of the General Parity Index (GPI) in Other small states in 2007 to that in 2010?
Keep it short and to the point. 1. What is the ratio of the General Parity Index (GPI) in Bhutan in 2007 to that in 2010?
Offer a very short reply. 0.97. What is the ratio of the General Parity Index (GPI) of Croatia in 2007 to that in 2010?
Your answer should be very brief. 1. What is the ratio of the General Parity Index (GPI) in Luxembourg in 2007 to that in 2010?
Keep it short and to the point. 0.99. What is the ratio of the General Parity Index (GPI) of Bhutan in 2007 to that in 2011?
Provide a short and direct response. 0.98. What is the ratio of the General Parity Index (GPI) of Croatia in 2007 to that in 2011?
Your answer should be compact. 1. What is the ratio of the General Parity Index (GPI) of Luxembourg in 2007 to that in 2011?
Provide a short and direct response. 0.98. What is the ratio of the General Parity Index (GPI) of Other small states in 2007 to that in 2012?
Give a very brief answer. 1. What is the ratio of the General Parity Index (GPI) of Bhutan in 2007 to that in 2012?
Ensure brevity in your answer.  0.97. What is the ratio of the General Parity Index (GPI) in Croatia in 2007 to that in 2012?
Keep it short and to the point. 1. What is the ratio of the General Parity Index (GPI) in Bhutan in 2008 to that in 2010?
Your response must be concise. 0.99. What is the ratio of the General Parity Index (GPI) of Croatia in 2008 to that in 2010?
Offer a terse response. 1. What is the ratio of the General Parity Index (GPI) in Luxembourg in 2008 to that in 2010?
Your answer should be very brief. 1. What is the ratio of the General Parity Index (GPI) of Other small states in 2008 to that in 2011?
Your answer should be very brief. 1.01. What is the ratio of the General Parity Index (GPI) of Bhutan in 2008 to that in 2011?
Provide a succinct answer. 1. What is the ratio of the General Parity Index (GPI) of Croatia in 2008 to that in 2011?
Give a very brief answer. 1. What is the ratio of the General Parity Index (GPI) in Luxembourg in 2008 to that in 2011?
Your answer should be compact. 0.99. What is the ratio of the General Parity Index (GPI) of Bhutan in 2008 to that in 2012?
Offer a very short reply. 0.99. What is the ratio of the General Parity Index (GPI) in Croatia in 2008 to that in 2012?
Your response must be concise. 1. What is the ratio of the General Parity Index (GPI) of Luxembourg in 2008 to that in 2012?
Offer a very short reply. 1. What is the ratio of the General Parity Index (GPI) of Other small states in 2010 to that in 2011?
Offer a terse response. 1. What is the ratio of the General Parity Index (GPI) of Bhutan in 2010 to that in 2011?
Provide a short and direct response. 1.01. What is the ratio of the General Parity Index (GPI) in Luxembourg in 2010 to that in 2011?
Offer a very short reply. 0.99. What is the ratio of the General Parity Index (GPI) of Luxembourg in 2010 to that in 2012?
Give a very brief answer. 1.01. What is the ratio of the General Parity Index (GPI) in Other small states in 2011 to that in 2012?
Ensure brevity in your answer.  1. What is the ratio of the General Parity Index (GPI) of Bhutan in 2011 to that in 2012?
Your response must be concise. 1. What is the ratio of the General Parity Index (GPI) of Croatia in 2011 to that in 2012?
Provide a succinct answer. 1. What is the ratio of the General Parity Index (GPI) of Luxembourg in 2011 to that in 2012?
Make the answer very short. 1.01. What is the difference between the highest and the second highest General Parity Index (GPI) of Other small states?
Offer a terse response. 0. What is the difference between the highest and the second highest General Parity Index (GPI) of Bhutan?
Offer a terse response. 0.01. What is the difference between the highest and the second highest General Parity Index (GPI) in Croatia?
Give a very brief answer. 0. What is the difference between the highest and the second highest General Parity Index (GPI) in Luxembourg?
Offer a terse response. 0.01. What is the difference between the highest and the lowest General Parity Index (GPI) in Other small states?
Offer a very short reply. 0.01. What is the difference between the highest and the lowest General Parity Index (GPI) of Bhutan?
Your answer should be compact. 0.05. What is the difference between the highest and the lowest General Parity Index (GPI) in Croatia?
Keep it short and to the point. 0.01. What is the difference between the highest and the lowest General Parity Index (GPI) in Luxembourg?
Your answer should be compact. 0.02. 